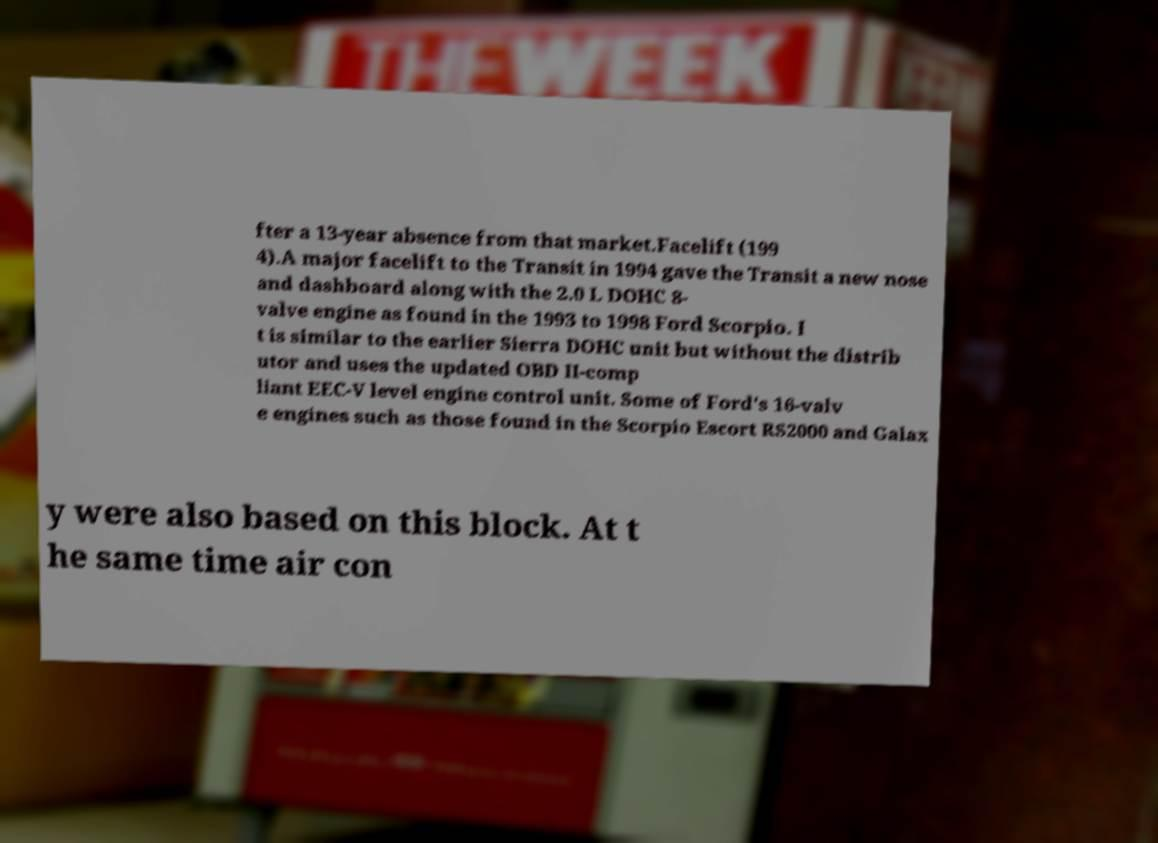Could you assist in decoding the text presented in this image and type it out clearly? fter a 13-year absence from that market.Facelift (199 4).A major facelift to the Transit in 1994 gave the Transit a new nose and dashboard along with the 2.0 L DOHC 8- valve engine as found in the 1993 to 1998 Ford Scorpio. I t is similar to the earlier Sierra DOHC unit but without the distrib utor and uses the updated OBD II-comp liant EEC-V level engine control unit. Some of Ford's 16-valv e engines such as those found in the Scorpio Escort RS2000 and Galax y were also based on this block. At t he same time air con 